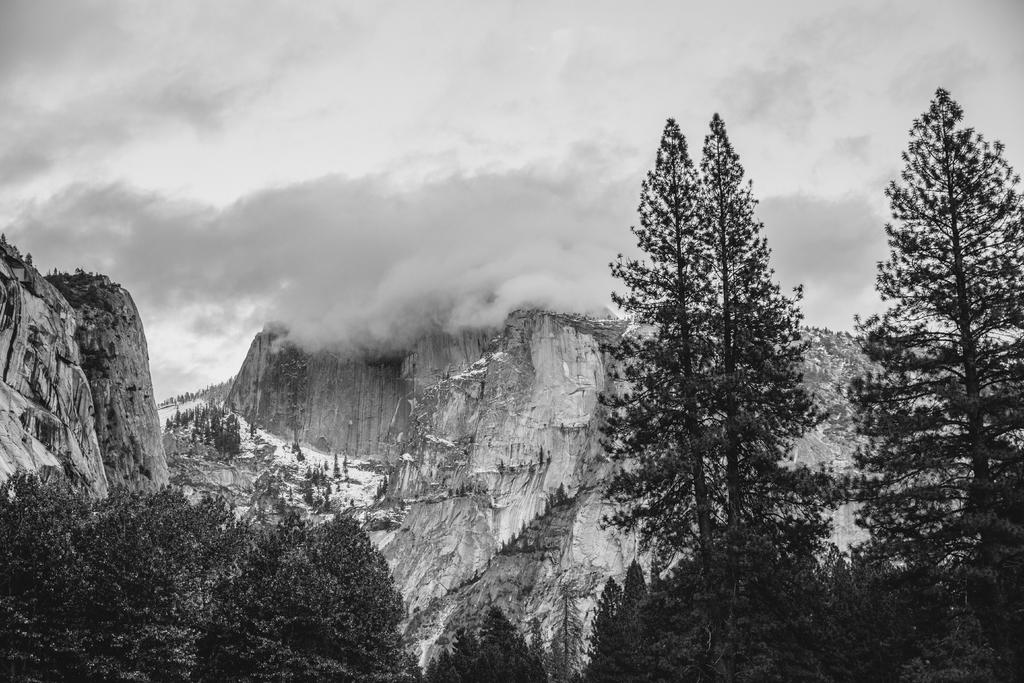What type of vegetation is in the foreground of the image? There are trees in the foreground of the image. What type of geographical feature is in the background of the image? There are mountains in the background of the image. What is the condition of the mountains in the image? The mountains have smoke in the image. What is visible at the top of the image? The sky is visible at the top of the image. What type of scarf is being used to cover the trees in the image? There is no scarf present in the image; it features trees in the foreground and mountains with smoke in the background. Can you see any beetles crawling on the mountains in the image? There are no beetles visible in the image; it only shows trees, mountains, smoke, and sky. 